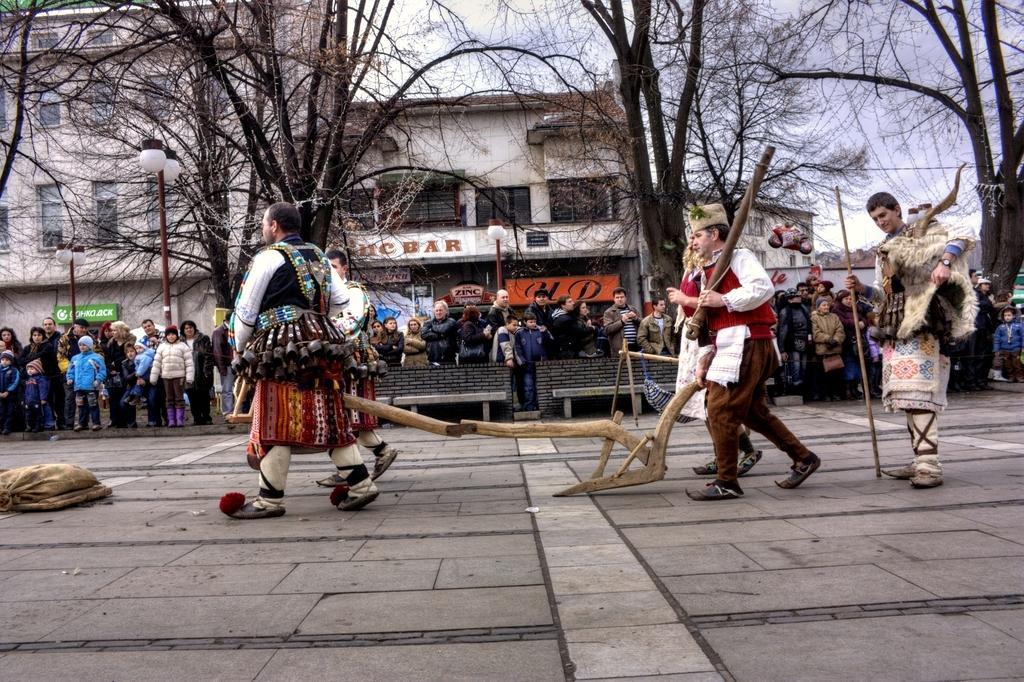Can you describe this image briefly? This image is clicked on the road. In the foreground there are few people walking. They are wearing costumes. Behind them there are benches and many people standing on the road. In the background there are buildings, trees and street light poles. There are boards with text on the buildings. At the top there is the sky. 